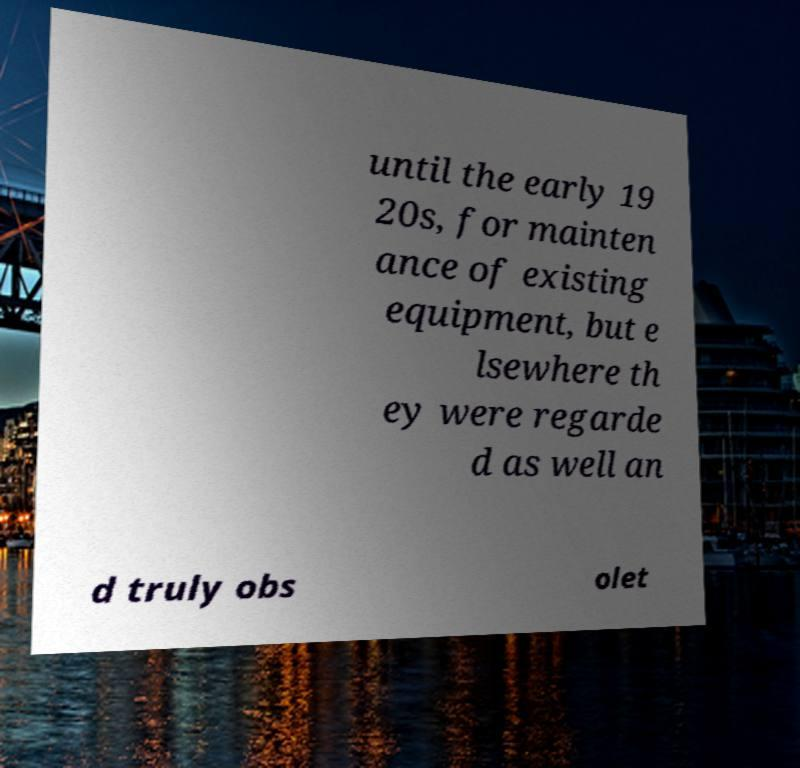Please read and relay the text visible in this image. What does it say? until the early 19 20s, for mainten ance of existing equipment, but e lsewhere th ey were regarde d as well an d truly obs olet 